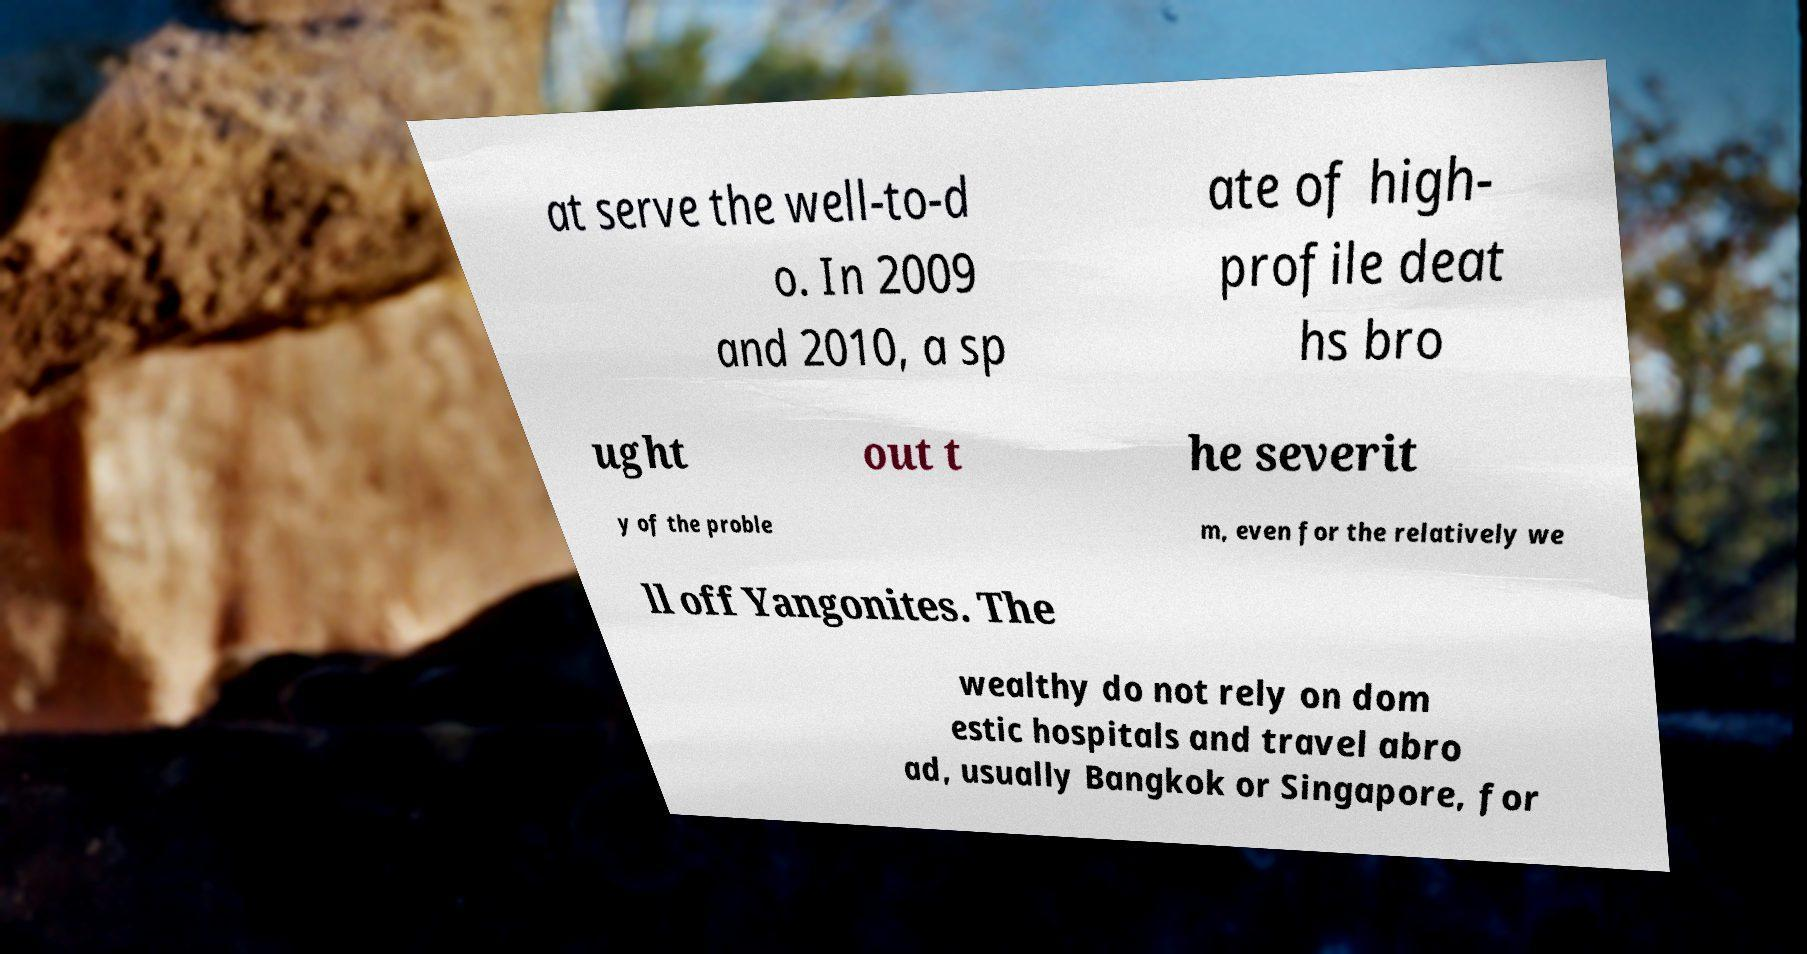Please read and relay the text visible in this image. What does it say? at serve the well-to-d o. In 2009 and 2010, a sp ate of high- profile deat hs bro ught out t he severit y of the proble m, even for the relatively we ll off Yangonites. The wealthy do not rely on dom estic hospitals and travel abro ad, usually Bangkok or Singapore, for 